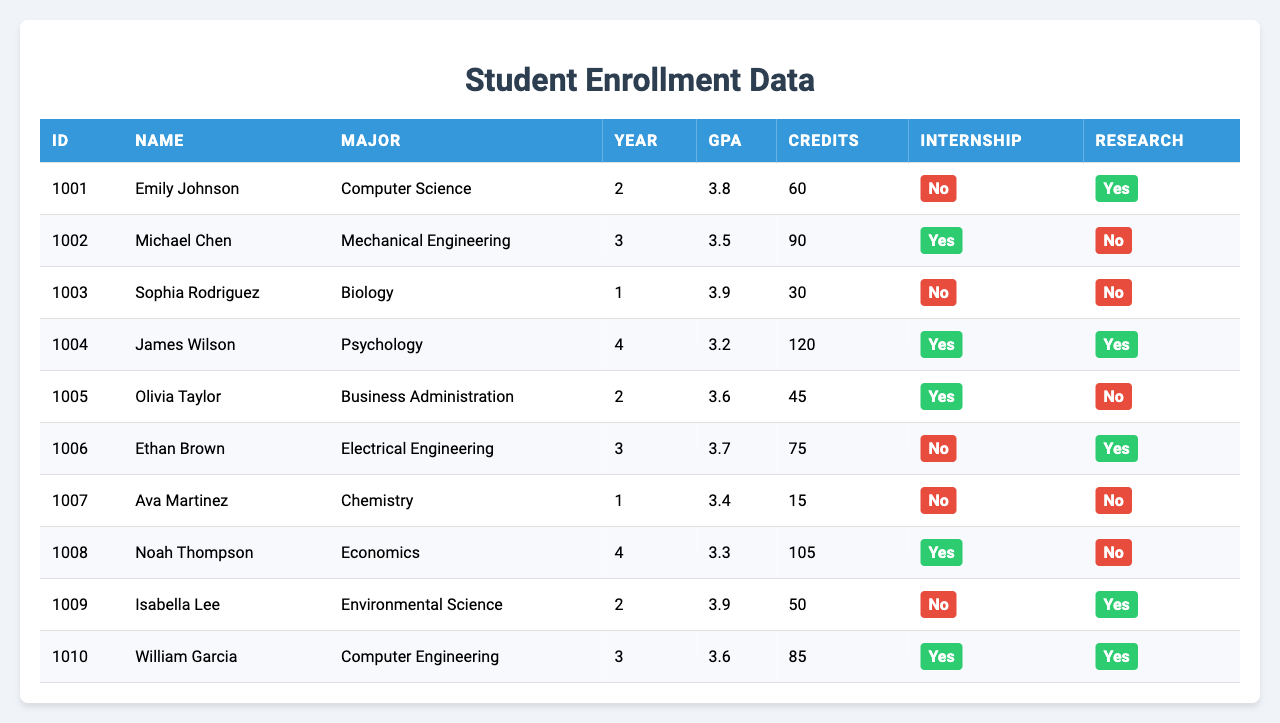What is the GPA of Ava Martinez? Look at the table and find the row for Ava Martinez. The GPA listed in her row is 3.4.
Answer: 3.4 Which major has the highest number of students? There are 10 students in total, and all have different majors. Therefore, each major has one student each.
Answer: Each major has one student How many students are majoring in Engineering-related fields? There are two fields: Mechanical Engineering and Electrical Engineering. Each has one student enrolled.
Answer: 2 Is there any student with a GPA above 3.8 who has completed more than 60 credits? Checking the table, Emily Johnson has a GPA of 3.8 and 60 credits, but no student has a GPA higher than 3.8 with more than 60 credits.
Answer: No What is the average GPA of students majoring in Computer Science and Computer Engineering? Emily Johnson has a GPA of 3.8 in Computer Science, and William Garcia has a GPA of 3.6 in Computer Engineering. The average is (3.8 + 3.6)/2 = 3.7.
Answer: 3.7 Which student has completed the most credits and what is their major? The table shows that James Wilson in Psychology has completed 120 credits, which is the highest among all.
Answer: James Wilson, Psychology How many students have both an internship and a research project? Looking through the table, James Wilson and William Garcia are the only two students marked with "Yes" for both internship and research.
Answer: 2 What are the majors of students who are in their final year? The table lists two final-year students: James Wilson majoring in Psychology and Noah Thompson majoring in Economics.
Answer: Psychology and Economics Are there any students with research projects who have not done internships? Reviewing the data, Isabella Lee and Emily Johnson are students with research projects who have not completed internships.
Answer: Yes What percentage of students have completed 60 or more credits? There are 10 students in total. 5 students have completed 60 or more credits (Michael Chen, James Wilson, Noah Thompson, William Garcia). Thus, the percentage is (5/10) * 100 = 50%.
Answer: 50% 